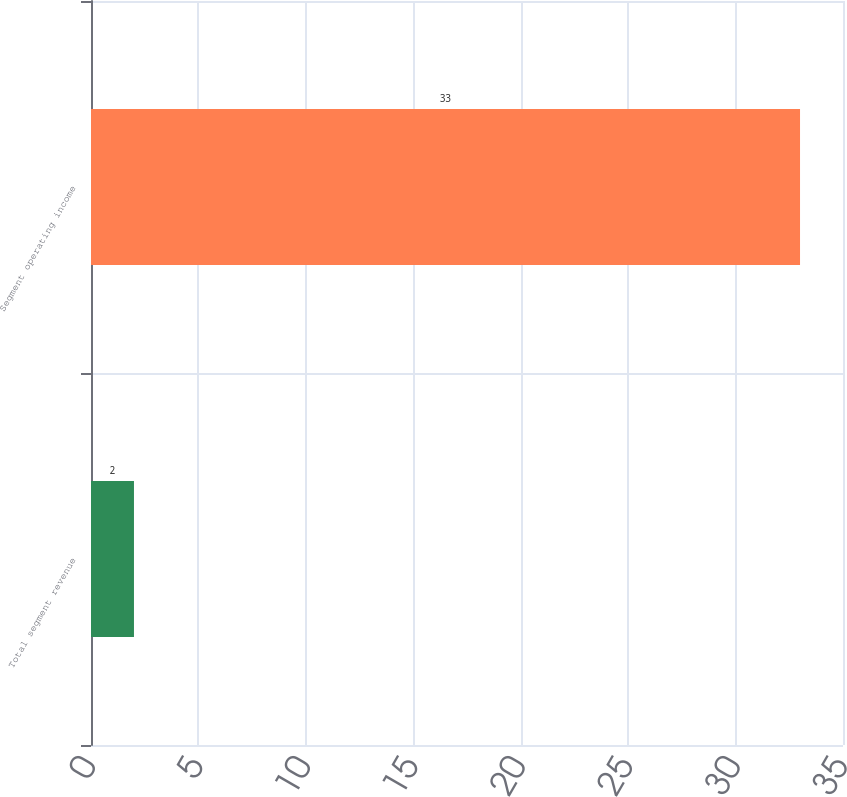<chart> <loc_0><loc_0><loc_500><loc_500><bar_chart><fcel>Total segment revenue<fcel>Segment operating income<nl><fcel>2<fcel>33<nl></chart> 